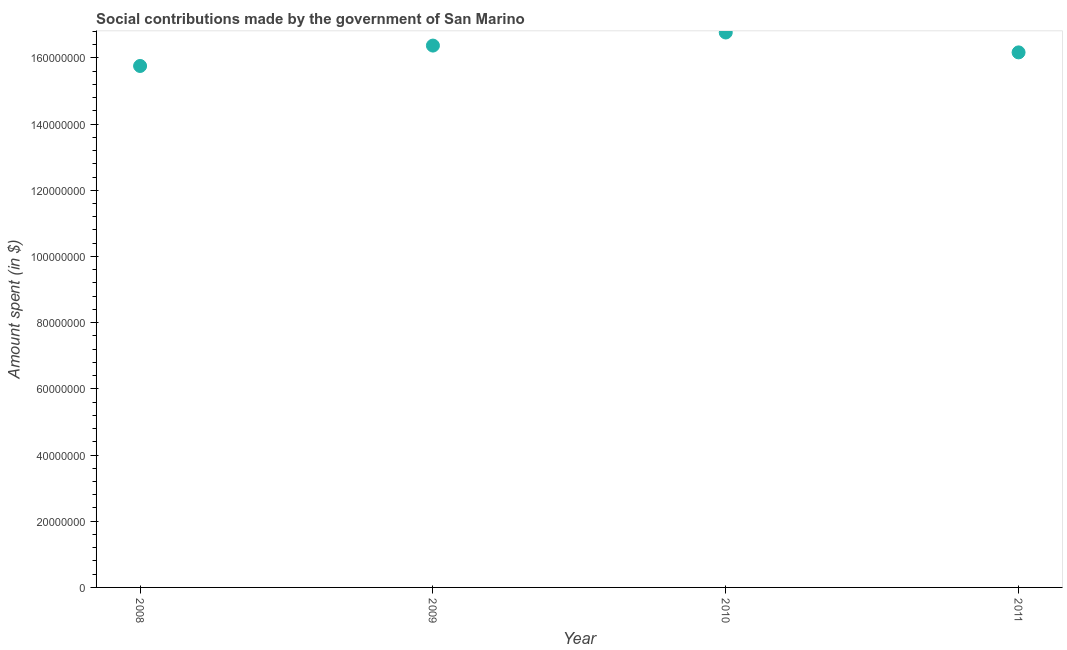What is the amount spent in making social contributions in 2008?
Keep it short and to the point. 1.58e+08. Across all years, what is the maximum amount spent in making social contributions?
Your response must be concise. 1.68e+08. Across all years, what is the minimum amount spent in making social contributions?
Your response must be concise. 1.58e+08. In which year was the amount spent in making social contributions maximum?
Give a very brief answer. 2010. In which year was the amount spent in making social contributions minimum?
Make the answer very short. 2008. What is the sum of the amount spent in making social contributions?
Give a very brief answer. 6.51e+08. What is the difference between the amount spent in making social contributions in 2008 and 2011?
Offer a very short reply. -4.11e+06. What is the average amount spent in making social contributions per year?
Provide a succinct answer. 1.63e+08. What is the median amount spent in making social contributions?
Offer a very short reply. 1.63e+08. In how many years, is the amount spent in making social contributions greater than 68000000 $?
Offer a terse response. 4. Do a majority of the years between 2011 and 2008 (inclusive) have amount spent in making social contributions greater than 48000000 $?
Give a very brief answer. Yes. What is the ratio of the amount spent in making social contributions in 2008 to that in 2009?
Your answer should be very brief. 0.96. What is the difference between the highest and the second highest amount spent in making social contributions?
Ensure brevity in your answer.  3.95e+06. What is the difference between the highest and the lowest amount spent in making social contributions?
Offer a terse response. 1.01e+07. Does the amount spent in making social contributions monotonically increase over the years?
Your answer should be very brief. No. How many years are there in the graph?
Offer a terse response. 4. Are the values on the major ticks of Y-axis written in scientific E-notation?
Keep it short and to the point. No. Does the graph contain any zero values?
Your answer should be compact. No. Does the graph contain grids?
Provide a short and direct response. No. What is the title of the graph?
Your answer should be very brief. Social contributions made by the government of San Marino. What is the label or title of the Y-axis?
Make the answer very short. Amount spent (in $). What is the Amount spent (in $) in 2008?
Provide a short and direct response. 1.58e+08. What is the Amount spent (in $) in 2009?
Keep it short and to the point. 1.64e+08. What is the Amount spent (in $) in 2010?
Make the answer very short. 1.68e+08. What is the Amount spent (in $) in 2011?
Your answer should be very brief. 1.62e+08. What is the difference between the Amount spent (in $) in 2008 and 2009?
Your response must be concise. -6.16e+06. What is the difference between the Amount spent (in $) in 2008 and 2010?
Your answer should be compact. -1.01e+07. What is the difference between the Amount spent (in $) in 2008 and 2011?
Offer a very short reply. -4.11e+06. What is the difference between the Amount spent (in $) in 2009 and 2010?
Your answer should be compact. -3.95e+06. What is the difference between the Amount spent (in $) in 2009 and 2011?
Ensure brevity in your answer.  2.05e+06. What is the difference between the Amount spent (in $) in 2010 and 2011?
Keep it short and to the point. 6.01e+06. What is the ratio of the Amount spent (in $) in 2008 to that in 2010?
Ensure brevity in your answer.  0.94. What is the ratio of the Amount spent (in $) in 2008 to that in 2011?
Provide a short and direct response. 0.97. What is the ratio of the Amount spent (in $) in 2009 to that in 2010?
Provide a short and direct response. 0.98. What is the ratio of the Amount spent (in $) in 2010 to that in 2011?
Make the answer very short. 1.04. 